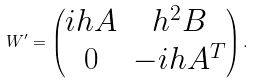Convert formula to latex. <formula><loc_0><loc_0><loc_500><loc_500>W ^ { \prime } = \left ( \begin{matrix} i h A & h ^ { 2 } B \\ 0 & - i h A ^ { T } \end{matrix} \right ) .</formula> 